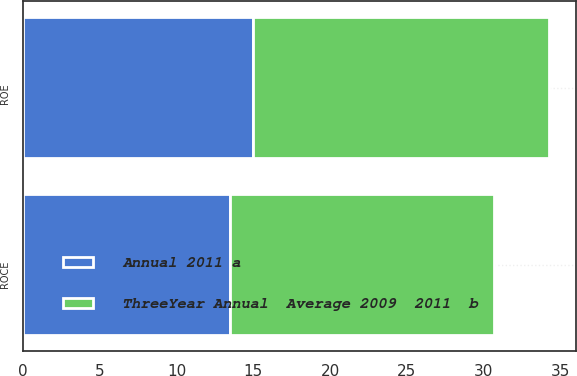Convert chart to OTSL. <chart><loc_0><loc_0><loc_500><loc_500><stacked_bar_chart><ecel><fcel>ROE<fcel>ROCE<nl><fcel>ThreeYear Annual  Average 2009  2011  b<fcel>19.3<fcel>17.2<nl><fcel>Annual 2011 a<fcel>15<fcel>13.5<nl></chart> 